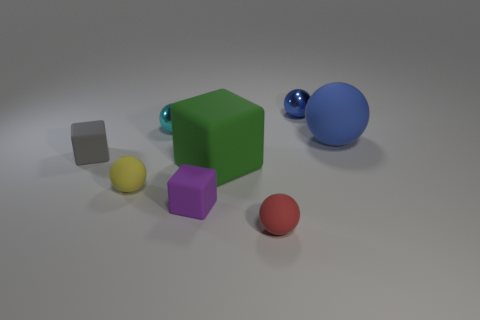The big ball that is the same material as the green cube is what color?
Make the answer very short. Blue. What is the size of the blue sphere that is on the left side of the big thing that is behind the large matte object that is in front of the big blue thing?
Make the answer very short. Small. Are there fewer tiny blue spheres than rubber things?
Your answer should be compact. Yes. There is another tiny matte thing that is the same shape as the gray thing; what color is it?
Provide a short and direct response. Purple. Is there a cyan thing that is left of the small metallic object on the right side of the metal thing to the left of the red object?
Keep it short and to the point. Yes. Is the big blue matte thing the same shape as the small red rubber thing?
Provide a short and direct response. Yes. Are there fewer purple blocks that are behind the tiny purple thing than cyan metal objects?
Give a very brief answer. Yes. There is a metal object that is to the left of the metallic sphere that is behind the small metallic thing that is on the left side of the tiny red matte ball; what color is it?
Make the answer very short. Cyan. What number of metallic things are big purple cubes or big spheres?
Your answer should be very brief. 0. Do the blue matte thing and the purple rubber thing have the same size?
Make the answer very short. No. 